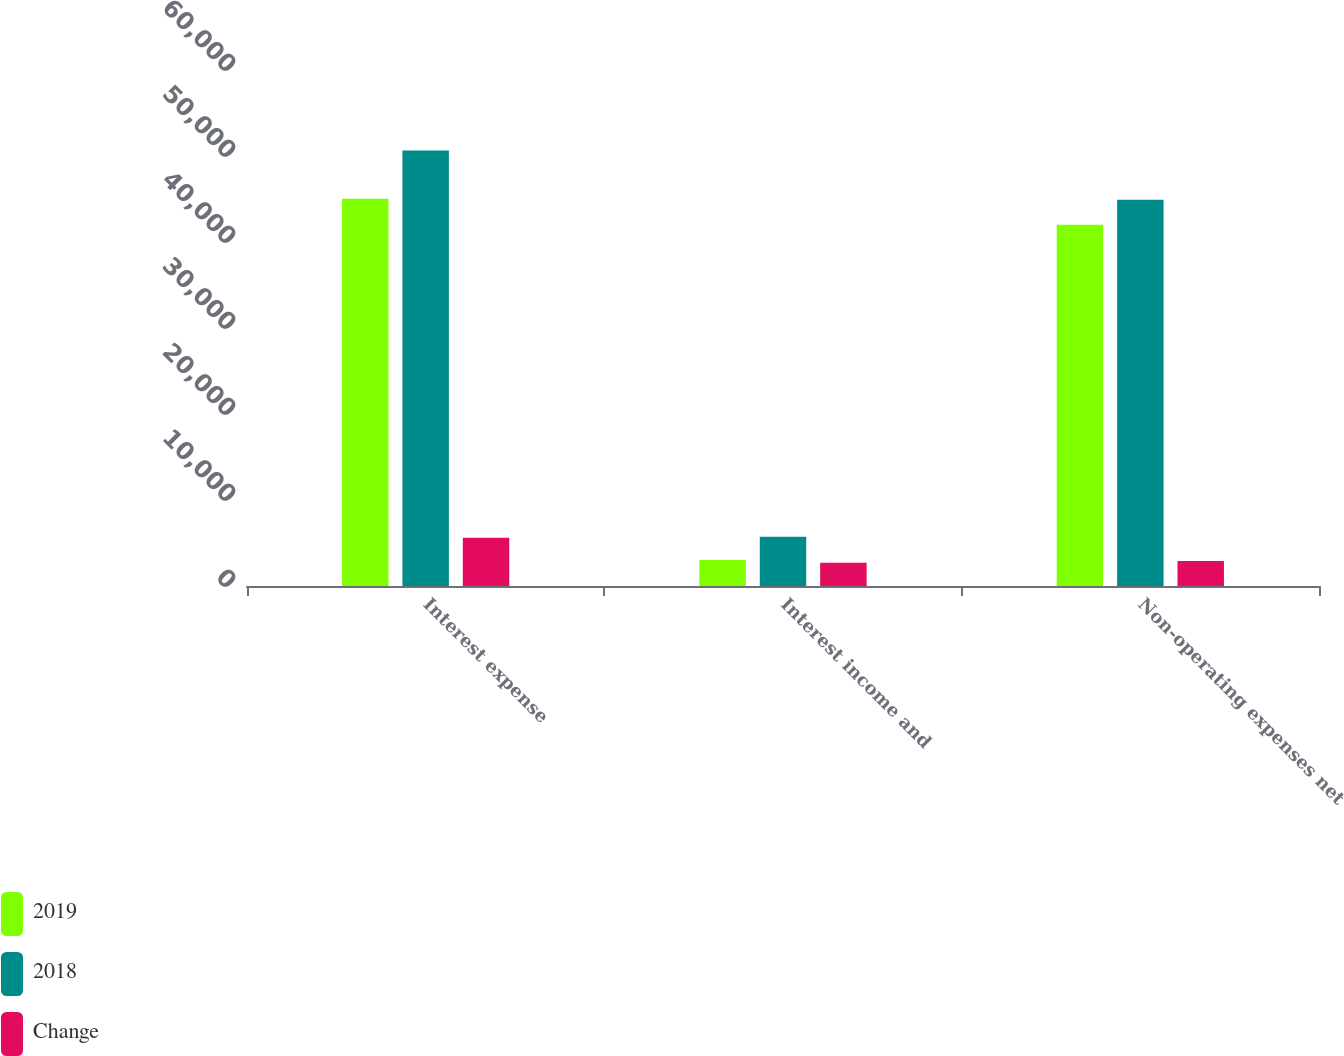<chart> <loc_0><loc_0><loc_500><loc_500><stacked_bar_chart><ecel><fcel>Interest expense<fcel>Interest income and<fcel>Non-operating expenses net<nl><fcel>2019<fcel>45015<fcel>3020<fcel>41995<nl><fcel>2018<fcel>50629<fcel>5728<fcel>44901<nl><fcel>Change<fcel>5614<fcel>2708<fcel>2906<nl></chart> 